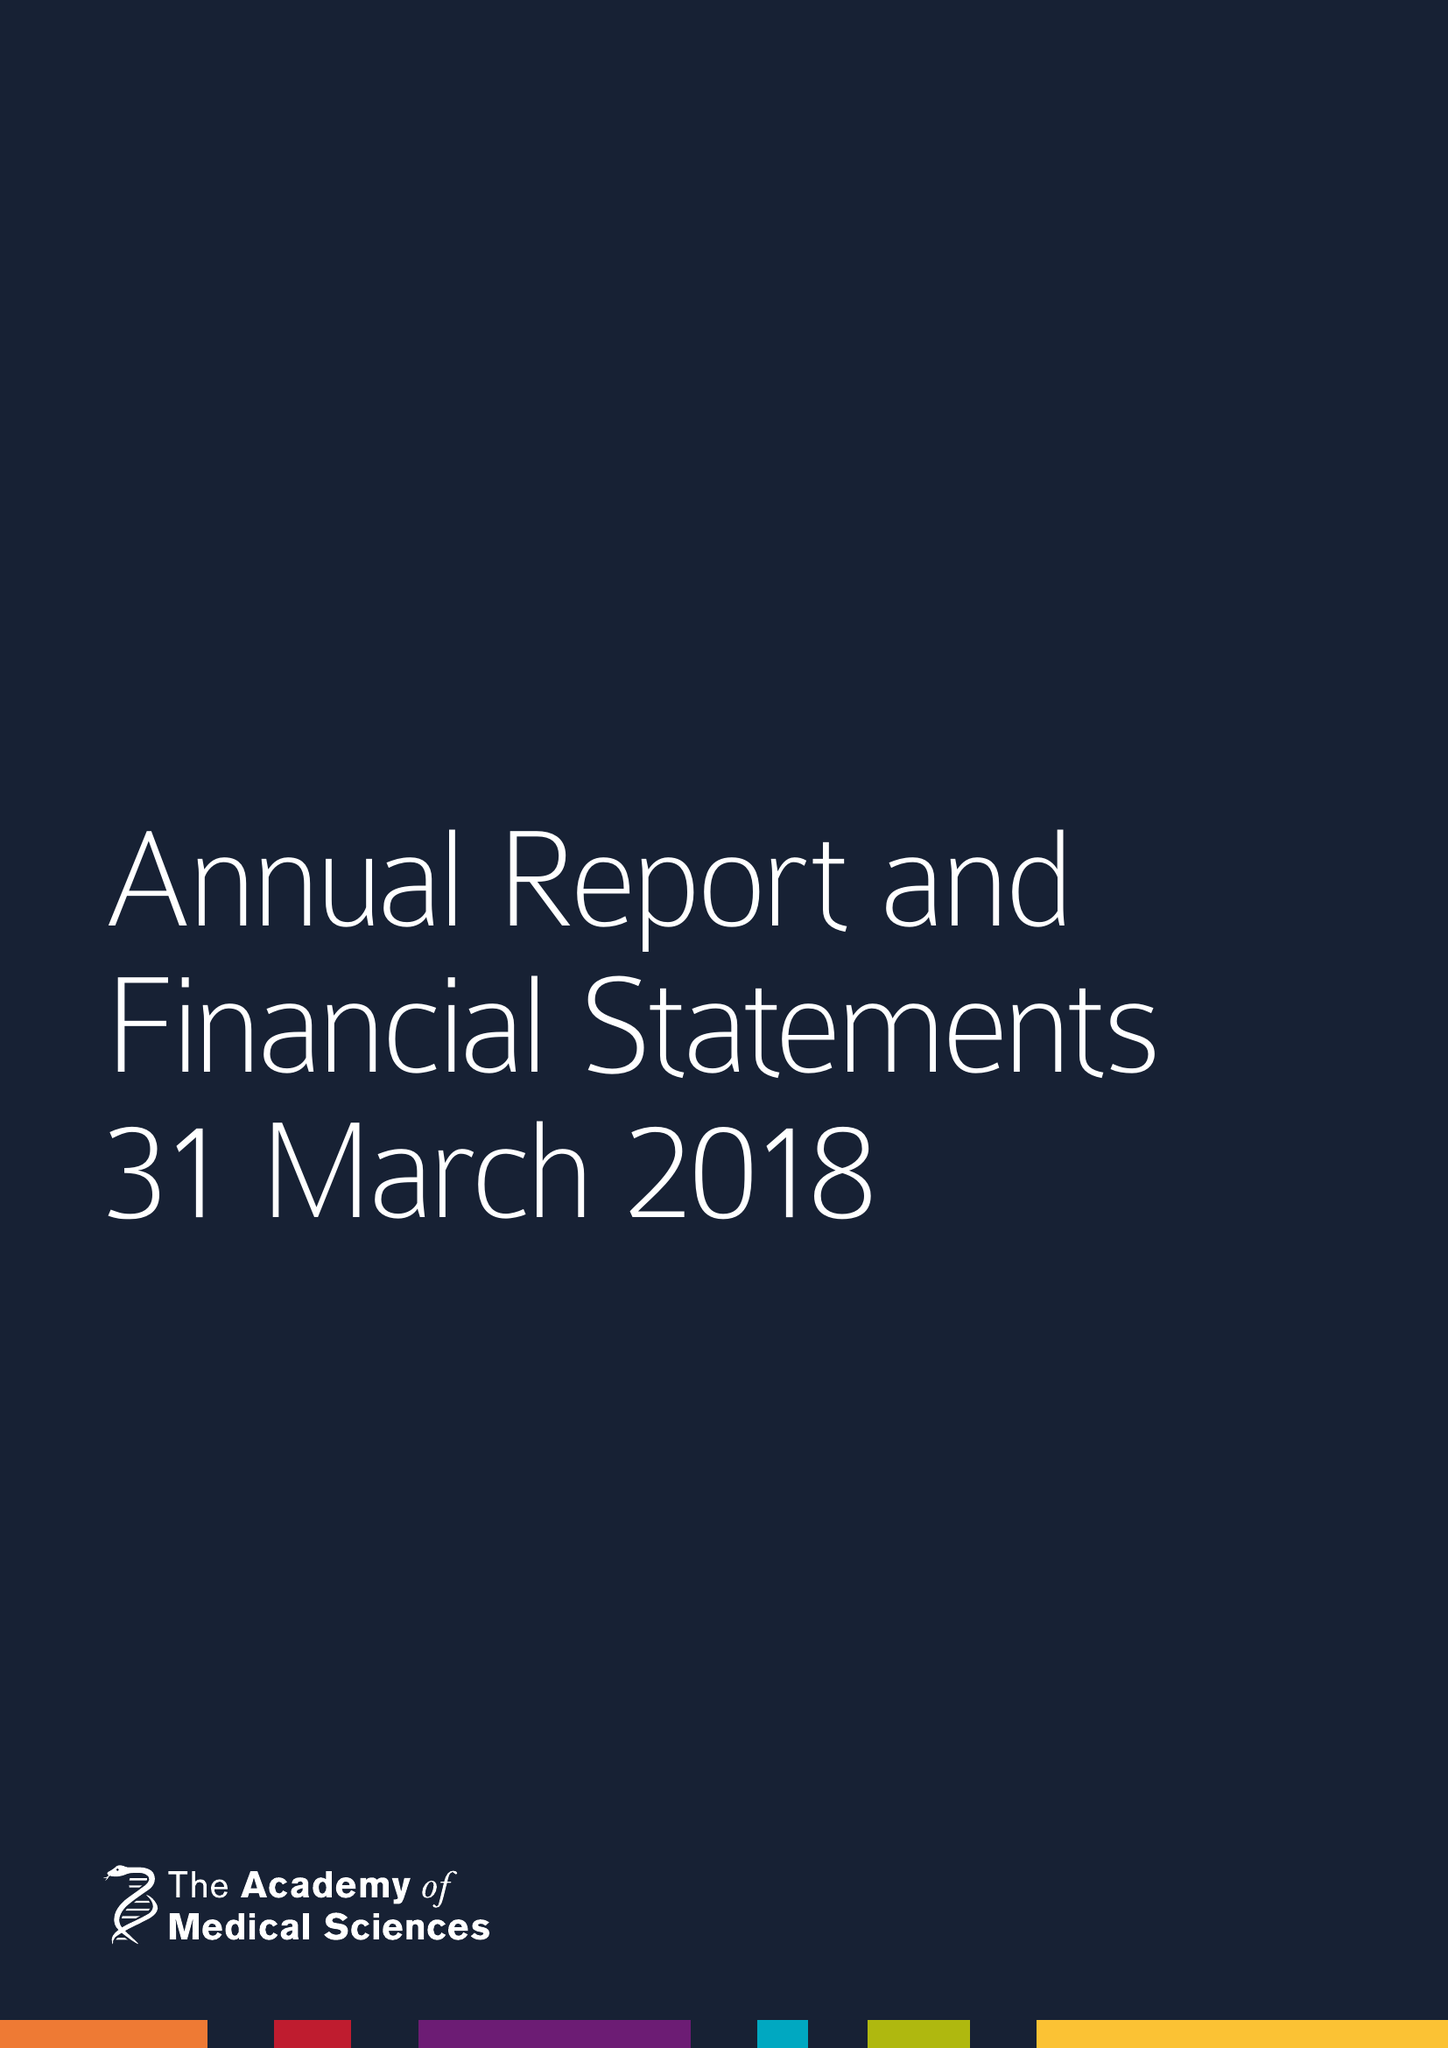What is the value for the spending_annually_in_british_pounds?
Answer the question using a single word or phrase. 11941776.00 